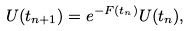Convert formula to latex. <formula><loc_0><loc_0><loc_500><loc_500>U ( t _ { n + 1 } ) = e ^ { - F ( t _ { n } ) } U ( t _ { n } ) , \</formula> 